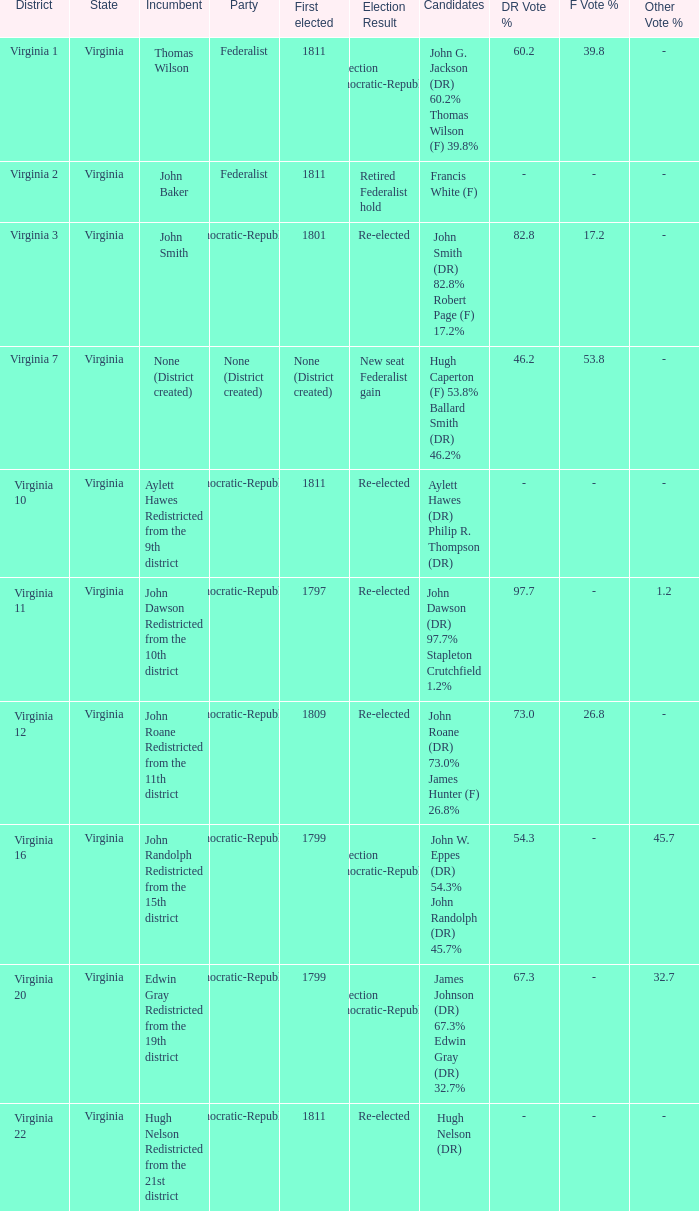Name the distrct for thomas wilson Virginia 1. 